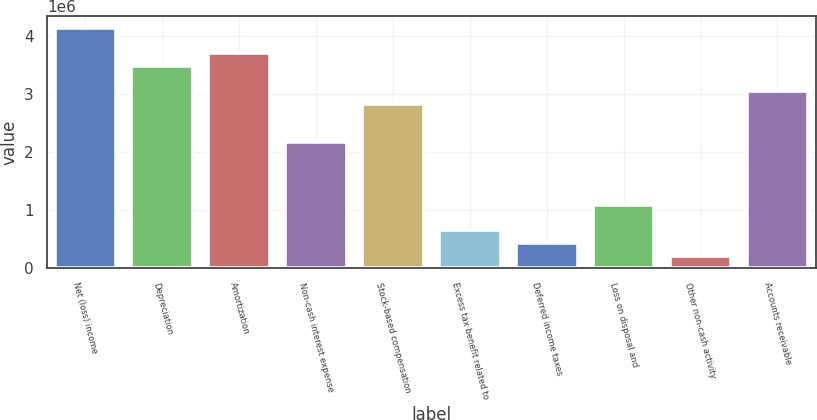Convert chart to OTSL. <chart><loc_0><loc_0><loc_500><loc_500><bar_chart><fcel>Net (loss) income<fcel>Depreciation<fcel>Amortization<fcel>Non-cash interest expense<fcel>Stock-based compensation<fcel>Excess tax benefit related to<fcel>Deferred income taxes<fcel>Loss on disposal and<fcel>Other non-cash activity<fcel>Accounts receivable<nl><fcel>4.13464e+06<fcel>3.48184e+06<fcel>3.69944e+06<fcel>2.17624e+06<fcel>2.82904e+06<fcel>653031<fcel>435431<fcel>1.08823e+06<fcel>217830<fcel>3.04664e+06<nl></chart> 